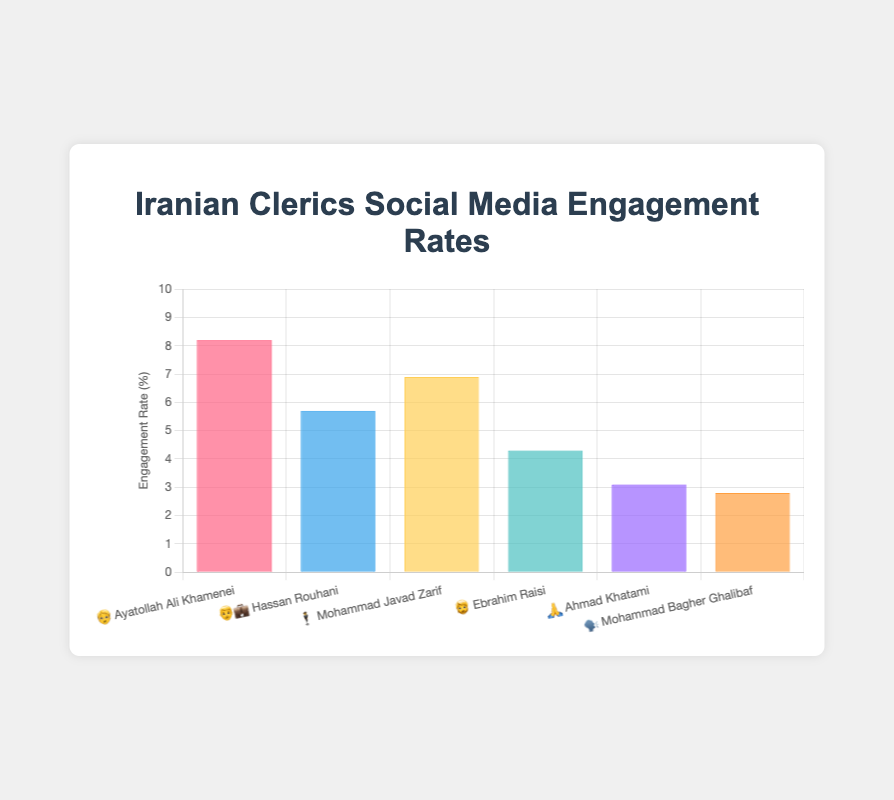What is the title of the chart? The chart's title is found at the top and typically summarizes the chart's content.
Answer: Iranian Clerics Social Media Engagement Rates What is the engagement rate of 🧓 Ayatollah Ali Khamenei? Find the bar labeled with 🧓 Ayatollah Ali Khamenei and check its height on the y-axis.
Answer: 8.2% Who has the lowest social media engagement rate among the clerics listed? Identify the bar with the shortest height in the chart.
Answer: 🗣️ Mohammad Bagher Ghalibaf Which cleric has a higher social media engagement rate: 🧓 Ayatollah Ali Khamenei or 👨‍💼 Hassan Rouhani? Compare the heights of the bars representing 🧓 Ayatollah Ali Khamenei and 👨‍💼 Hassan Rouhani.
Answer: 🧓 Ayatollah Ali Khamenei What is the total social media engagement rate for 🧓 Ayatollah Ali Khamenei and 🕴️ Mohammad Javad Zarif combined? Sum the engagement rates of 🧓 Ayatollah Ali Khamenei (8.2%) and 🕴️ Mohammad Javad Zarif (6.9%). 8.2% + 6.9% = 15.1%
Answer: 15.1% Who has a higher engagement rate: 🕴️ Mohammad Javad Zarif or current President 🧔 Ebrahim Raisi? Look at the bars for 🕴️ Mohammad Javad Zarif and 🧔 Ebrahim Raisi and compare their heights.
Answer: 🕴️ Mohammad Javad Zarif Rank the clerics from highest to lowest engagement rate. Order the clerics based on the height of their bars from tallest to shortest.
Answer: 🧓 Ayatollah Ali Khamenei, 🕴️ Mohammad Javad Zarif, 👨‍💼 Hassan Rouhani, 🧔 Ebrahim Raisi, 🙏 Ahmad Khatami, 🗣️ Mohammad Bagher Ghalibaf What is the difference in engagement rate between the clerics with the highest and lowest rates? Subtract the lowest engagement rate (2.8% for 🗣️ Mohammad Bagher Ghalibaf) from the highest (8.2% for 🧓 Ayatollah Ali Khamenei). 8.2% - 2.8% = 5.4%
Answer: 5.4% How many clerics have an engagement rate above 5%? Count the bars that reach above the 5% mark on the y-axis.
Answer: 3 